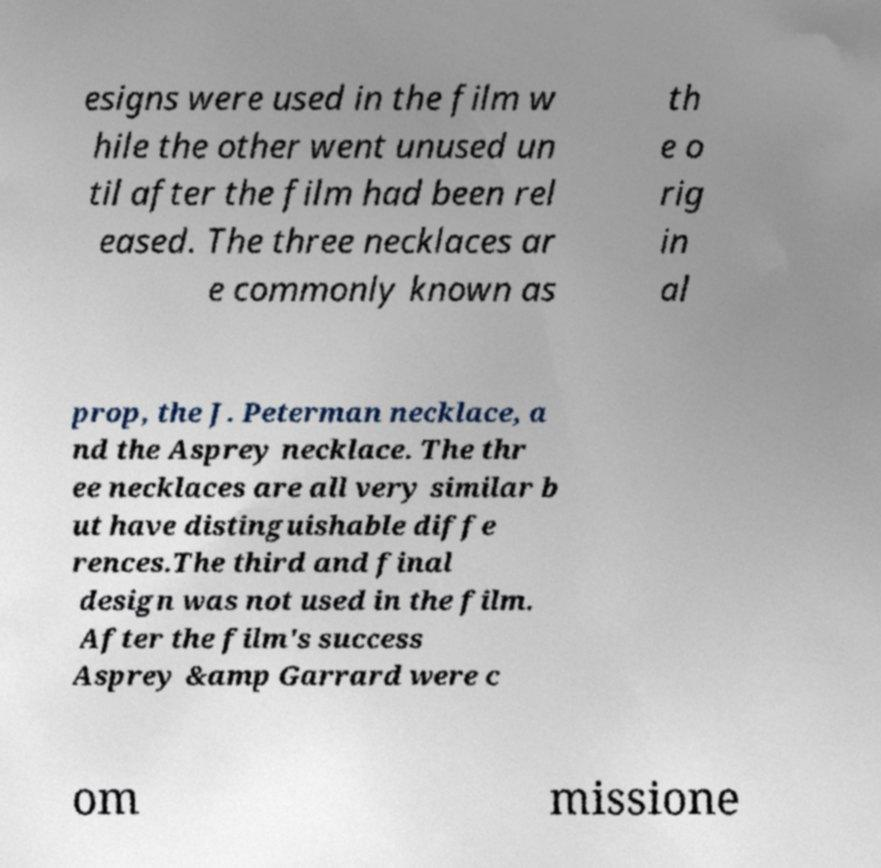Can you accurately transcribe the text from the provided image for me? esigns were used in the film w hile the other went unused un til after the film had been rel eased. The three necklaces ar e commonly known as th e o rig in al prop, the J. Peterman necklace, a nd the Asprey necklace. The thr ee necklaces are all very similar b ut have distinguishable diffe rences.The third and final design was not used in the film. After the film's success Asprey &amp Garrard were c om missione 